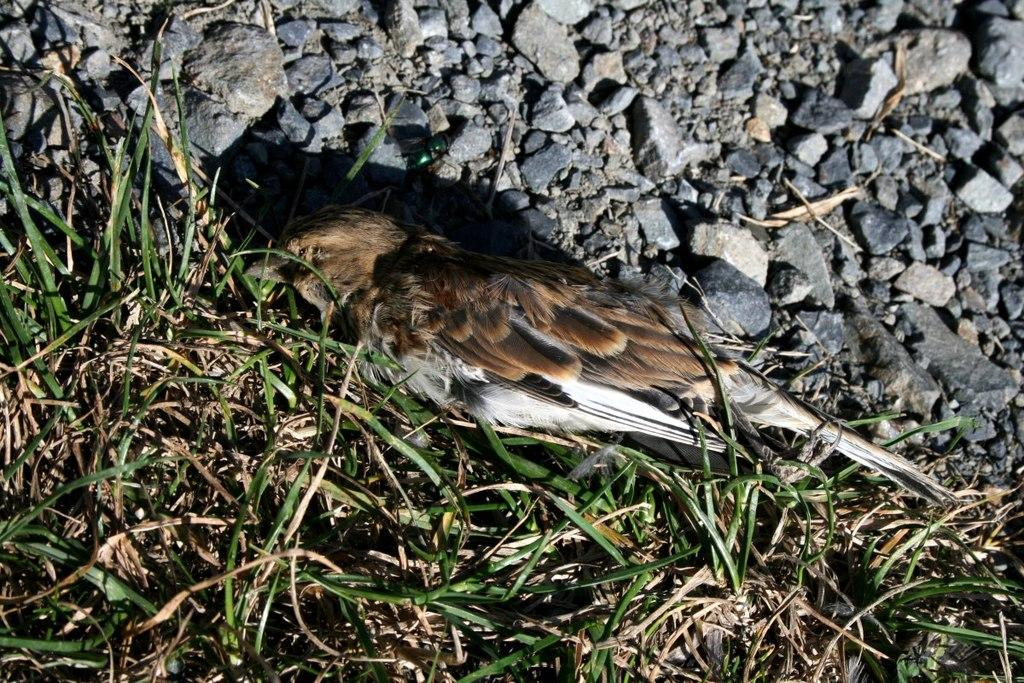What type of animal can be seen on the ground in the image? There is a bird on the ground in the image. What type of vegetation is visible in the image? There is grass visible in the image. What else can be found on the ground in the image? There are stones on the ground in the image. Is the bird holding an umbrella in the image? No, the bird is not holding an umbrella in the image. What is the bird doing while reading a book in the image? There is no indication that the bird is reading a book in the image. 